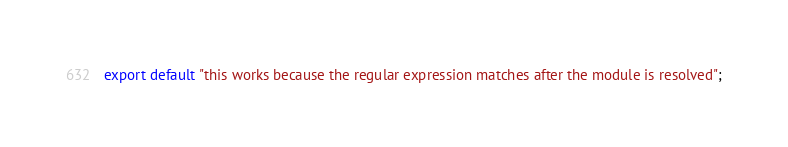<code> <loc_0><loc_0><loc_500><loc_500><_JavaScript_>export default "this works because the regular expression matches after the module is resolved";
</code> 